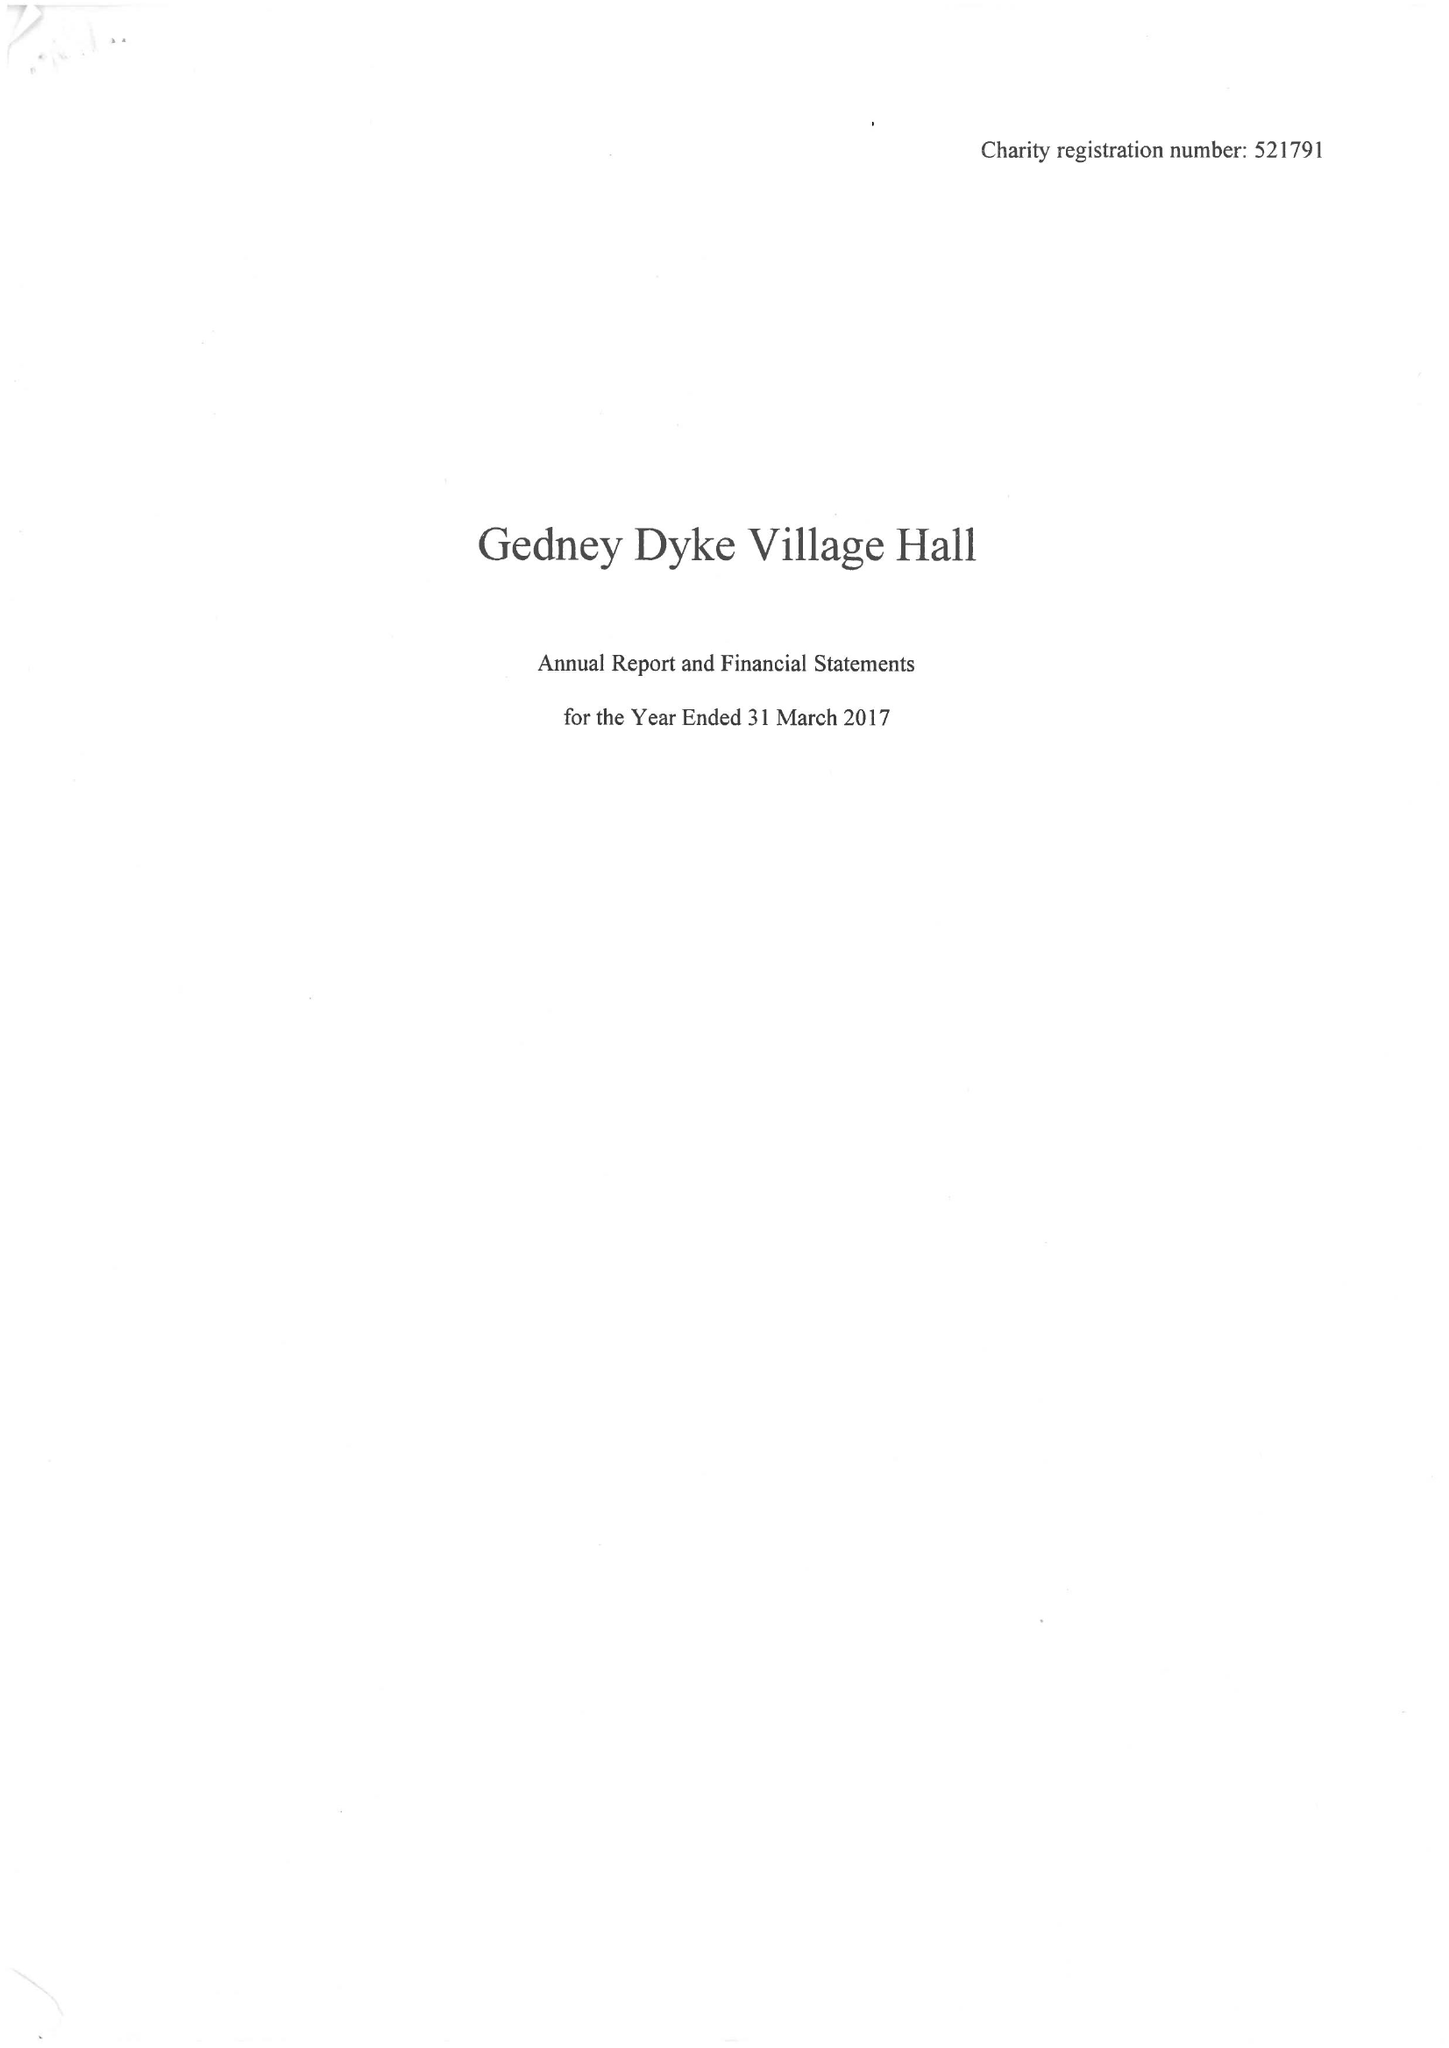What is the value for the income_annually_in_british_pounds?
Answer the question using a single word or phrase. 41086.00 